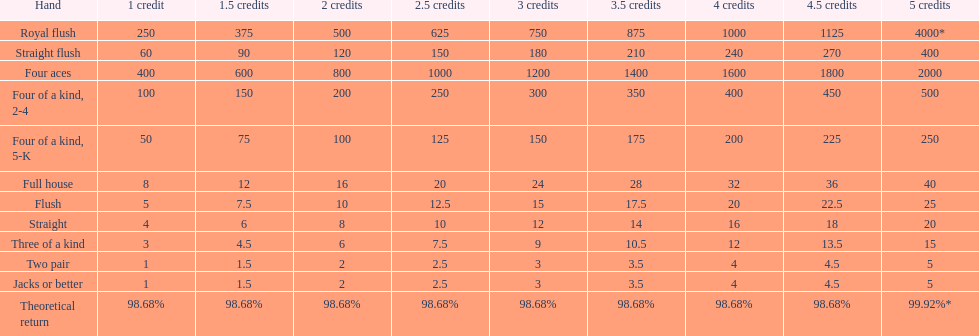Write the full table. {'header': ['Hand', '1 credit', '1.5 credits', '2 credits', '2.5 credits', '3 credits', '3.5 credits', '4 credits', '4.5 credits', '5 credits'], 'rows': [['Royal flush', '250', '375', '500', '625', '750', '875', '1000', '1125', '4000*'], ['Straight flush', '60', '90', '120', '150', '180', '210', '240', '270', '400'], ['Four aces', '400', '600', '800', '1000', '1200', '1400', '1600', '1800', '2000'], ['Four of a kind, 2-4', '100', '150', '200', '250', '300', '350', '400', '450', '500'], ['Four of a kind, 5-K', '50', '75', '100', '125', '150', '175', '200', '225', '250'], ['Full house', '8', '12', '16', '20', '24', '28', '32', '36', '40'], ['Flush', '5', '7.5', '10', '12.5', '15', '17.5', '20', '22.5', '25'], ['Straight', '4', '6', '8', '10', '12', '14', '16', '18', '20'], ['Three of a kind', '3', '4.5', '6', '7.5', '9', '10.5', '12', '13.5', '15'], ['Two pair', '1', '1.5', '2', '2.5', '3', '3.5', '4', '4.5', '5'], ['Jacks or better', '1', '1.5', '2', '2.5', '3', '3.5', '4', '4.5', '5'], ['Theoretical return', '98.68%', '98.68%', '98.68%', '98.68%', '98.68%', '98.68%', '98.68%', '98.68%', '99.92%*']]} The number of flush wins at one credit to equal one flush win at 5 credits. 5. 